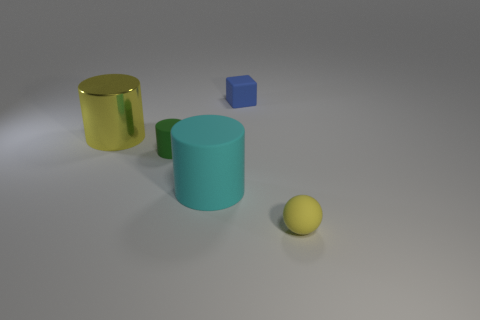Subtract all rubber cylinders. How many cylinders are left? 1 Add 5 red matte cylinders. How many objects exist? 10 Subtract 1 cubes. How many cubes are left? 0 Add 5 big yellow metal cylinders. How many big yellow metal cylinders are left? 6 Add 3 large purple shiny cylinders. How many large purple shiny cylinders exist? 3 Subtract all cyan cylinders. How many cylinders are left? 2 Subtract 0 brown balls. How many objects are left? 5 Subtract all cylinders. How many objects are left? 2 Subtract all green cylinders. Subtract all brown cubes. How many cylinders are left? 2 Subtract all blue cubes. How many brown spheres are left? 0 